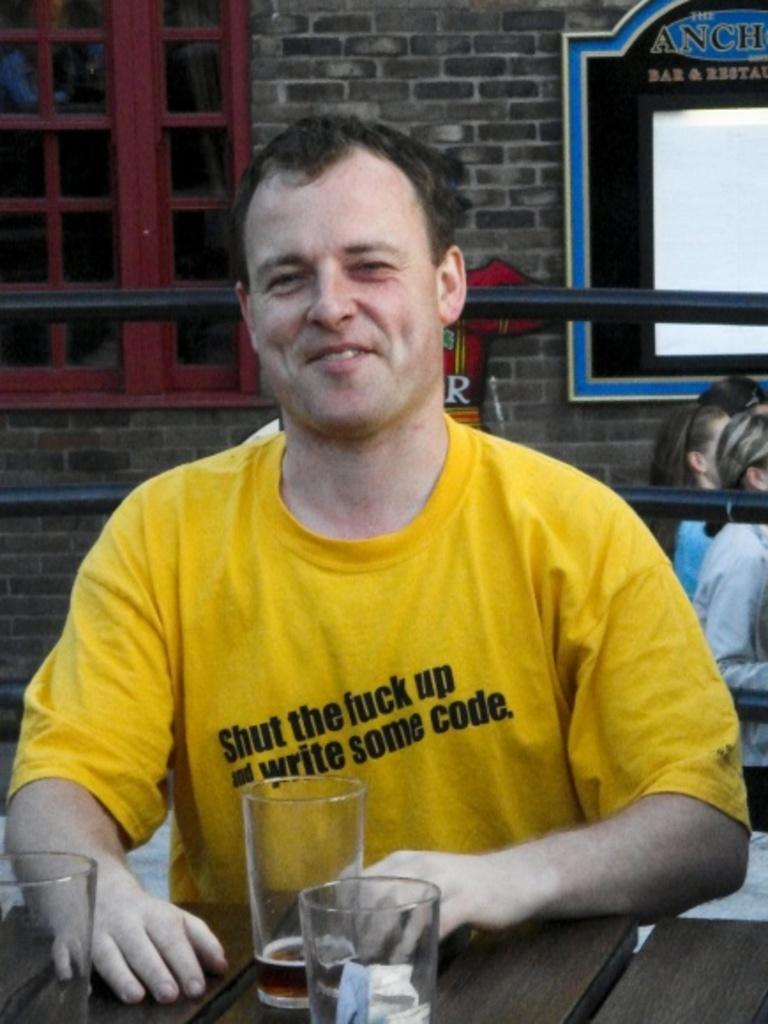What is the person in the image doing? The person is sitting in the image. Where is the person sitting? The person is sitting in front of a table. What can be seen on the table? There are glasses on the table. What is visible behind the person? There is a fence behind the person. What is happening in the background of the image? There is a group of people walking in front of a building. How many copies of the door are visible in the image? There is no door present in the image. Can you describe the flock of birds flying in the sky in the image? There are no birds or flocks visible in the image. 